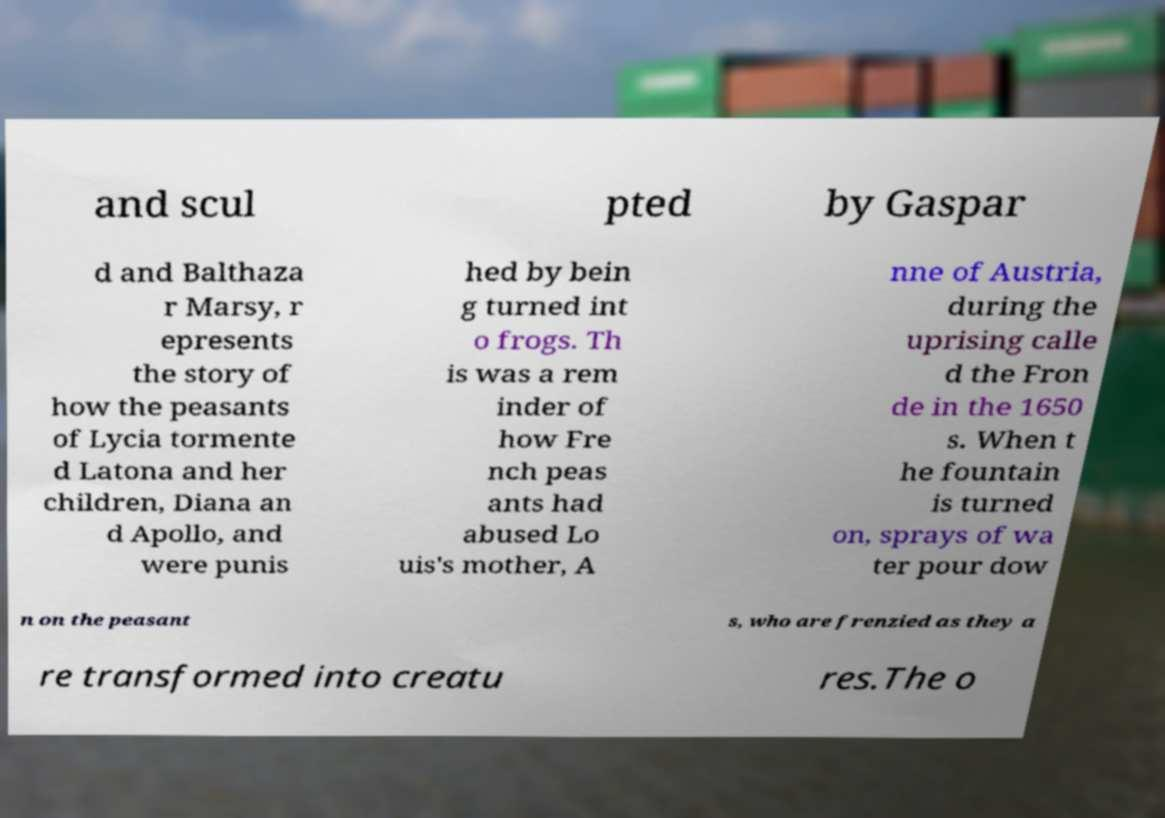For documentation purposes, I need the text within this image transcribed. Could you provide that? and scul pted by Gaspar d and Balthaza r Marsy, r epresents the story of how the peasants of Lycia tormente d Latona and her children, Diana an d Apollo, and were punis hed by bein g turned int o frogs. Th is was a rem inder of how Fre nch peas ants had abused Lo uis's mother, A nne of Austria, during the uprising calle d the Fron de in the 1650 s. When t he fountain is turned on, sprays of wa ter pour dow n on the peasant s, who are frenzied as they a re transformed into creatu res.The o 